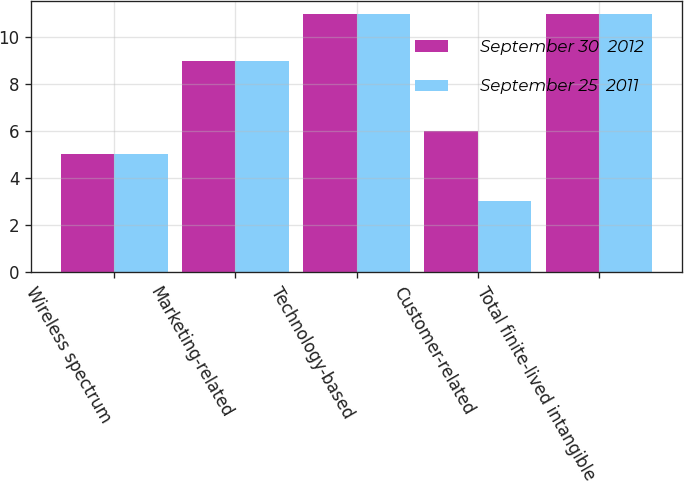<chart> <loc_0><loc_0><loc_500><loc_500><stacked_bar_chart><ecel><fcel>Wireless spectrum<fcel>Marketing-related<fcel>Technology-based<fcel>Customer-related<fcel>Total finite-lived intangible<nl><fcel>September 30  2012<fcel>5<fcel>9<fcel>11<fcel>6<fcel>11<nl><fcel>September 25  2011<fcel>5<fcel>9<fcel>11<fcel>3<fcel>11<nl></chart> 